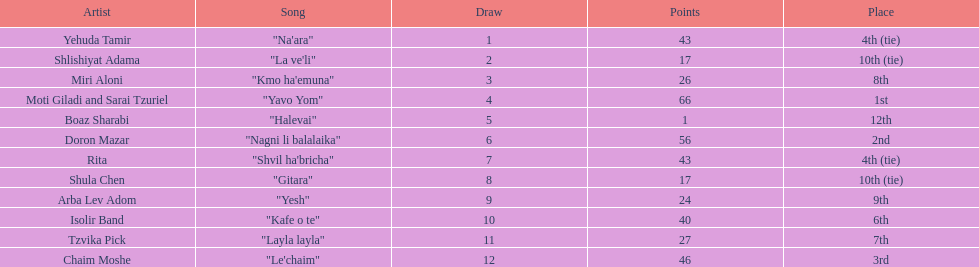What song is listed in the table right before layla layla? "Kafe o te". Give me the full table as a dictionary. {'header': ['Artist', 'Song', 'Draw', 'Points', 'Place'], 'rows': [['Yehuda Tamir', '"Na\'ara"', '1', '43', '4th (tie)'], ['Shlishiyat Adama', '"La ve\'li"', '2', '17', '10th (tie)'], ['Miri Aloni', '"Kmo ha\'emuna"', '3', '26', '8th'], ['Moti Giladi and Sarai Tzuriel', '"Yavo Yom"', '4', '66', '1st'], ['Boaz Sharabi', '"Halevai"', '5', '1', '12th'], ['Doron Mazar', '"Nagni li balalaika"', '6', '56', '2nd'], ['Rita', '"Shvil ha\'bricha"', '7', '43', '4th (tie)'], ['Shula Chen', '"Gitara"', '8', '17', '10th (tie)'], ['Arba Lev Adom', '"Yesh"', '9', '24', '9th'], ['Isolir Band', '"Kafe o te"', '10', '40', '6th'], ['Tzvika Pick', '"Layla layla"', '11', '27', '7th'], ['Chaim Moshe', '"Le\'chaim"', '12', '46', '3rd']]} 